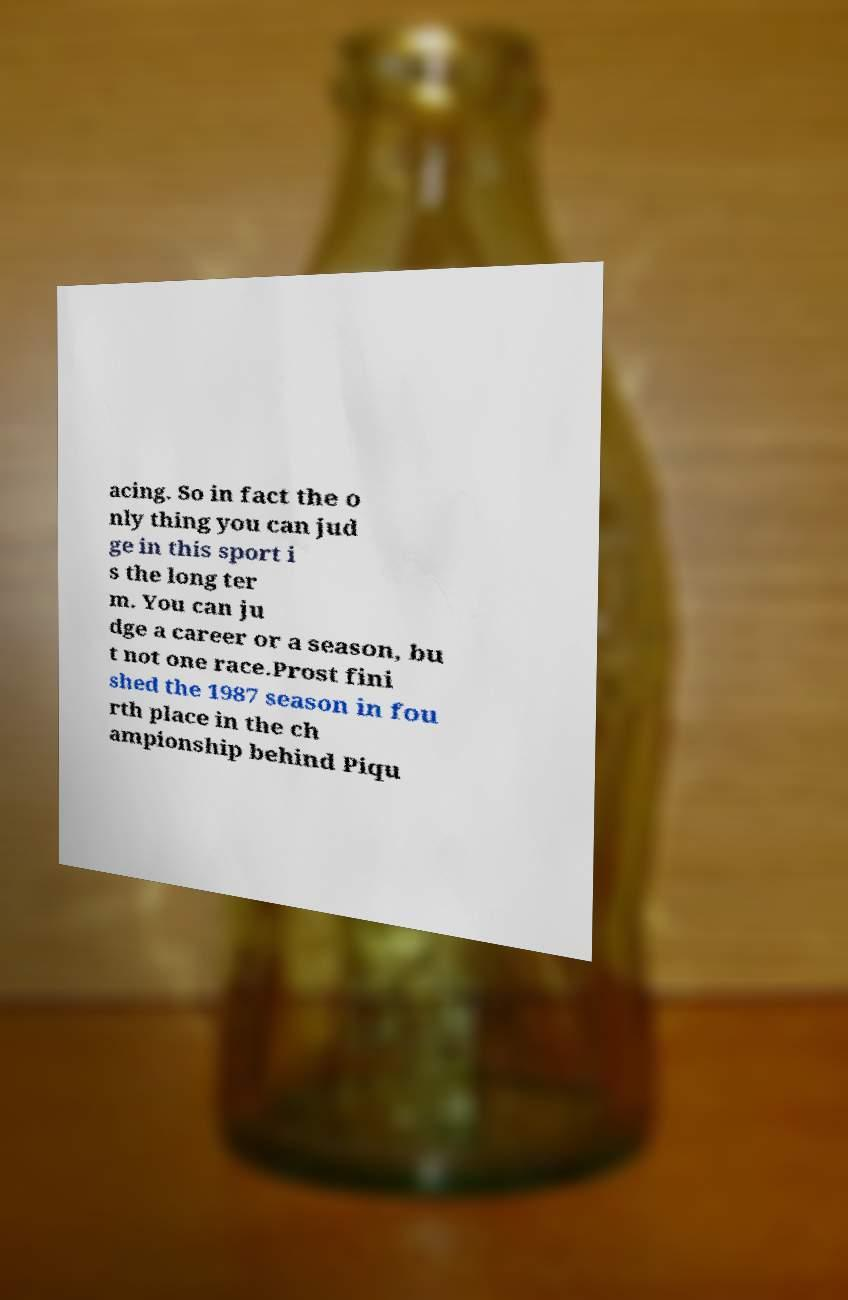I need the written content from this picture converted into text. Can you do that? acing. So in fact the o nly thing you can jud ge in this sport i s the long ter m. You can ju dge a career or a season, bu t not one race.Prost fini shed the 1987 season in fou rth place in the ch ampionship behind Piqu 